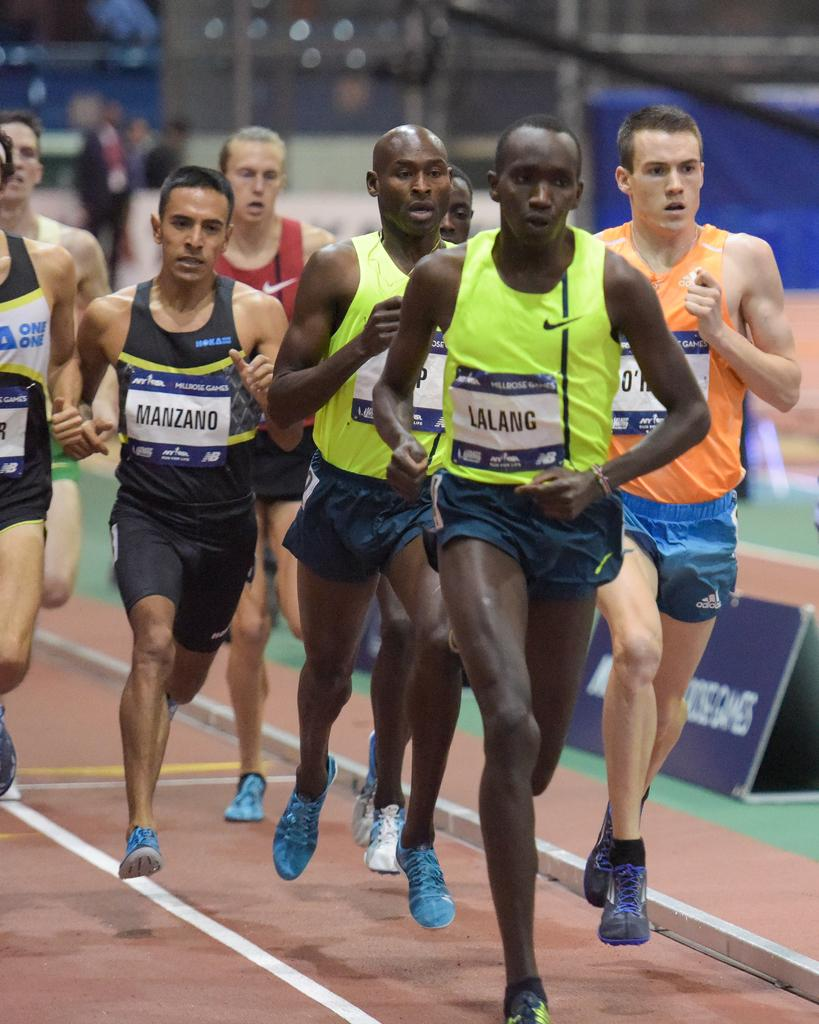<image>
Describe the image concisely. Men are racing on a track, Lalanc in the lead. 